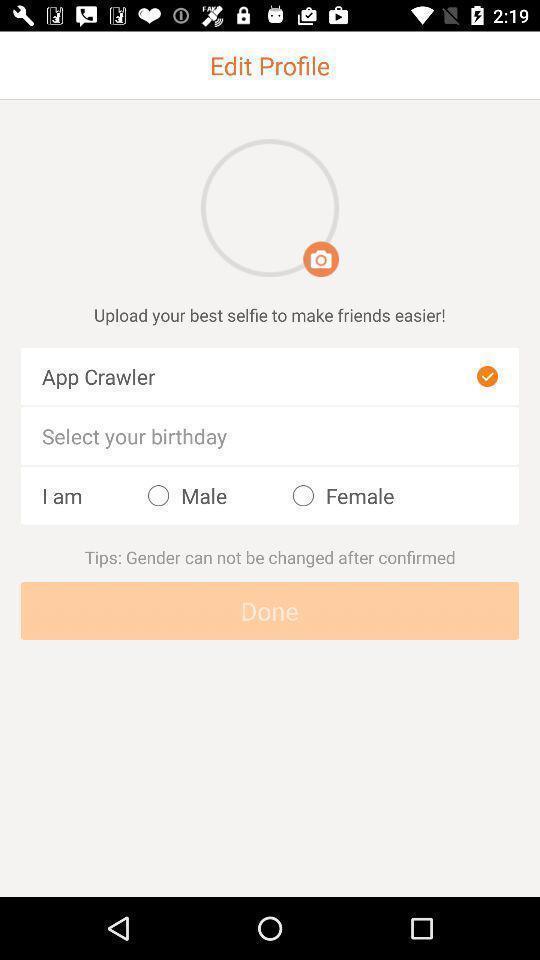Please provide a description for this image. Page showing the input profile details field. 